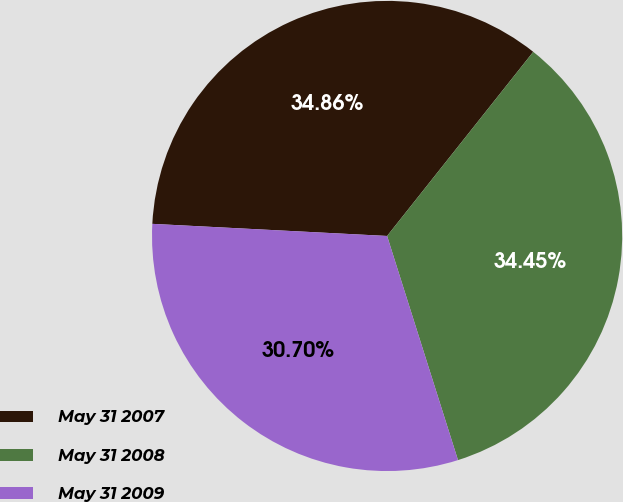<chart> <loc_0><loc_0><loc_500><loc_500><pie_chart><fcel>May 31 2007<fcel>May 31 2008<fcel>May 31 2009<nl><fcel>34.86%<fcel>34.45%<fcel>30.7%<nl></chart> 